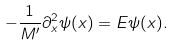<formula> <loc_0><loc_0><loc_500><loc_500>- \frac { 1 } { M ^ { \prime } } \partial _ { x } ^ { 2 } \psi ( x ) = E \psi ( x ) .</formula> 